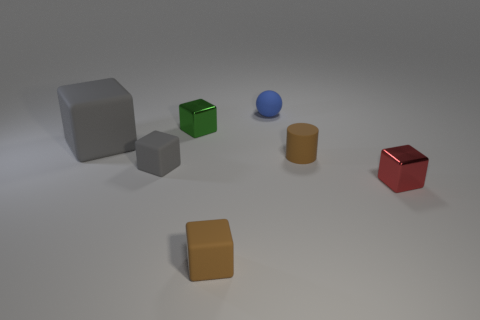Add 2 tiny red metal things. How many objects exist? 9 Subtract all large cubes. How many cubes are left? 4 Subtract all blocks. How many objects are left? 2 Subtract all green cubes. How many cubes are left? 4 Add 4 large objects. How many large objects are left? 5 Add 6 tiny blue metal spheres. How many tiny blue metal spheres exist? 6 Subtract 1 blue spheres. How many objects are left? 6 Subtract 1 balls. How many balls are left? 0 Subtract all yellow cylinders. Subtract all green blocks. How many cylinders are left? 1 Subtract all purple spheres. How many cyan cylinders are left? 0 